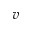<formula> <loc_0><loc_0><loc_500><loc_500>v</formula> 